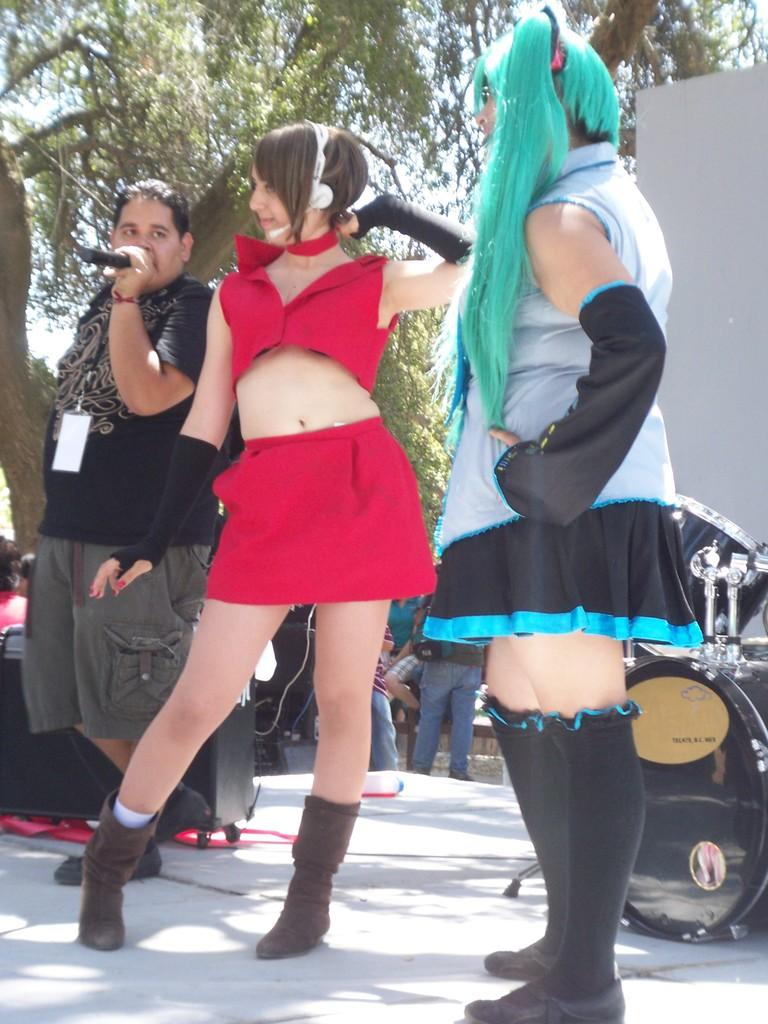What is happening in the middle of the image? There are people standing in the middle of the image. What can be seen on the right side of the image? There are objects on the right side of the image. What is visible in the background of the image? Trees are visible in the background of the image. What type of song is being sung by the cat in the image? There is no cat present in the image, and therefore no song can be heard. What team are the people in the image supporting? The provided facts do not mention any teams or affiliations, so it cannot be determined which team the people might be supporting. 